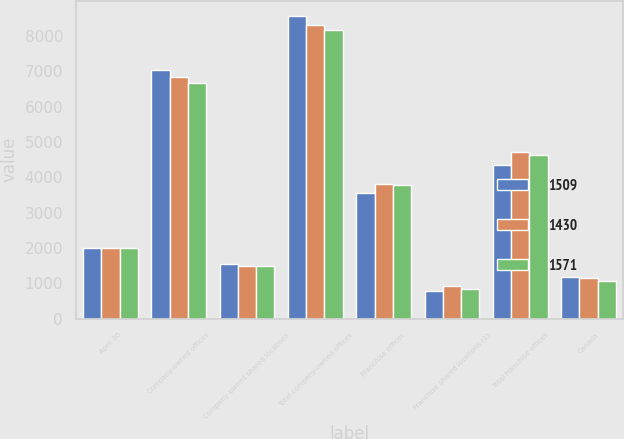Convert chart to OTSL. <chart><loc_0><loc_0><loc_500><loc_500><stacked_bar_chart><ecel><fcel>April 30<fcel>Company-owned offices<fcel>Company-owned shared locations<fcel>Total company-owned offices<fcel>Franchise offices<fcel>Franchise shared locations (1)<fcel>Total franchise offices<fcel>Canada<nl><fcel>1509<fcel>2009<fcel>7029<fcel>1542<fcel>8571<fcel>3565<fcel>787<fcel>4352<fcel>1193<nl><fcel>1430<fcel>2008<fcel>6835<fcel>1478<fcel>8313<fcel>3812<fcel>913<fcel>4725<fcel>1143<nl><fcel>1571<fcel>2007<fcel>6669<fcel>1488<fcel>8157<fcel>3784<fcel>843<fcel>4627<fcel>1070<nl></chart> 